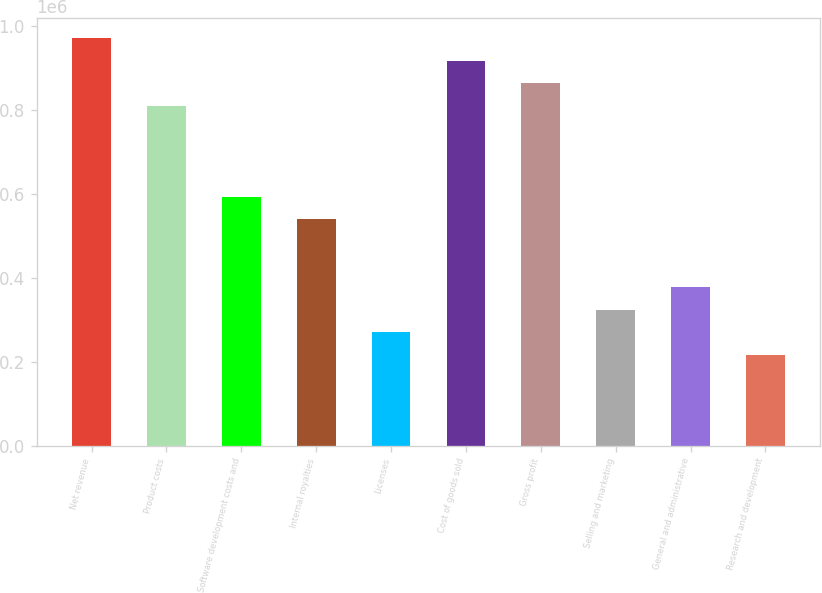<chart> <loc_0><loc_0><loc_500><loc_500><bar_chart><fcel>Net revenue<fcel>Product costs<fcel>Software development costs and<fcel>Internal royalties<fcel>Licenses<fcel>Cost of goods sold<fcel>Gross profit<fcel>Selling and marketing<fcel>General and administrative<fcel>Research and development<nl><fcel>971657<fcel>809714<fcel>593791<fcel>539810<fcel>269906<fcel>917676<fcel>863695<fcel>323887<fcel>377867<fcel>215925<nl></chart> 